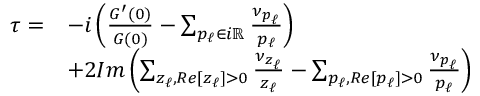<formula> <loc_0><loc_0><loc_500><loc_500>\begin{array} { r } { \begin{array} { r l } { \tau = } & { - i \left ( \frac { G ^ { \prime } ( 0 ) } { G ( 0 ) } - \sum _ { p _ { \ell } \in i \mathbb { R } } \frac { \nu _ { p _ { \ell } } } { p _ { \ell } } \right ) } \\ & { + 2 I m \left ( \sum _ { z _ { \ell } , R e [ z _ { \ell } ] > 0 } \frac { \nu _ { z _ { \ell } } } { z _ { \ell } } - \sum _ { p _ { \ell } , R e [ p _ { \ell } ] > 0 } \frac { \nu _ { p _ { \ell } } } { p _ { \ell } } \right ) } \end{array} } \end{array}</formula> 